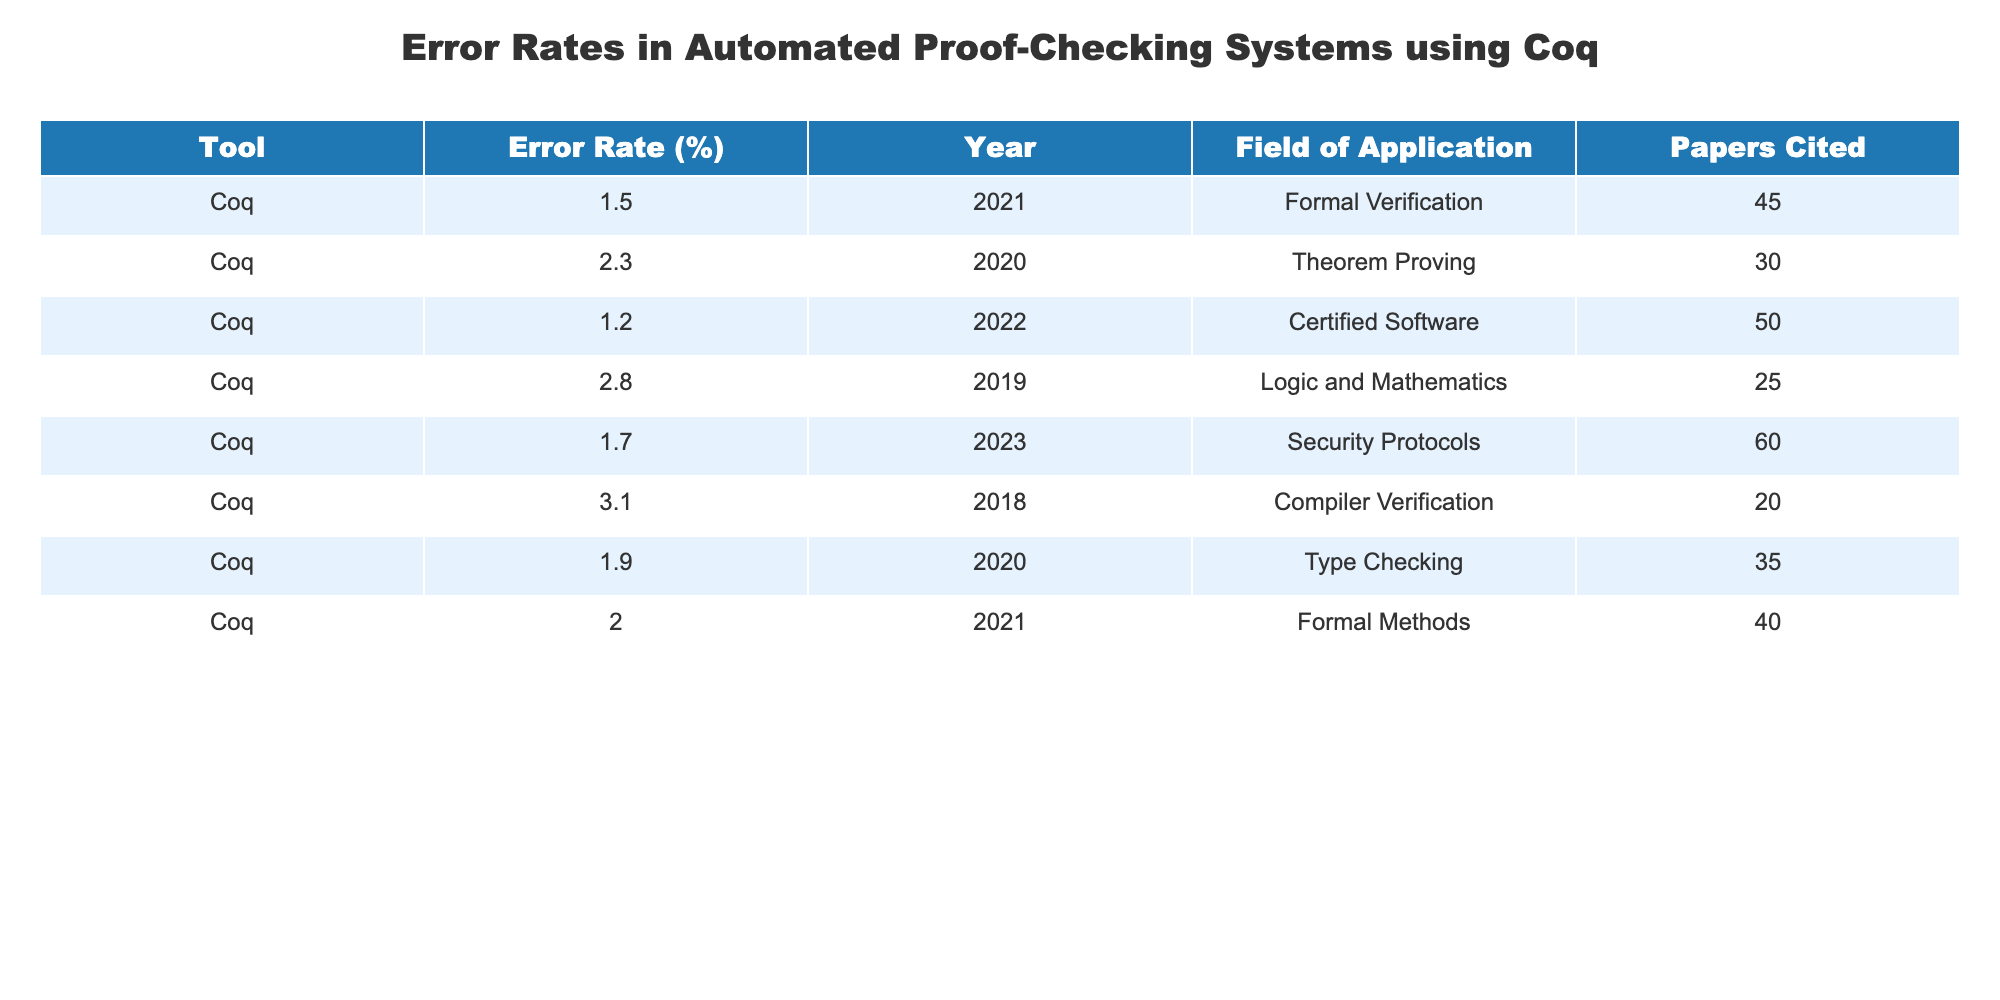What is the highest error rate recorded for Coq in the table? The table lists the error rates for Coq from various years and fields of application. Scanning through the "Error Rate (%)" column, the highest value recorded is 3.1%.
Answer: 3.1% What year was the lowest error rate reported? By examining the "Error Rate (%)" column, the lowest value is 1.2%, which corresponds to the year 2022. Therefore, the year 2022 had the lowest error rate.
Answer: 2022 How many different fields of application are represented in this table? The table includes unique fields of application listed in the "Field of Application" column. By counting the distinct entries, there are six different fields represented.
Answer: 6 What is the average error rate for the years listed? To find the average error rate, sum all rates: 1.5 + 2.3 + 1.2 + 2.8 + 1.7 + 3.1 + 1.9 + 2.0 = 16.5. There are 8 entries, so the average is 16.5 / 8 = 2.0625, which rounds to 2.06.
Answer: 2.06 Did the error rate for Coq in security protocols increase or decrease from the previous year? The error rate listed for security protocols in 2023 is 1.7%. The previous rate for 2022 (which is certified software) is 1.2%. Since we don't have the direct comparison to 2022 security protocols, we cannot determine a trend for security protocols specifically. However, in general, we see other fields may fluctuate.
Answer: Not applicable Can you list the error rates in chronological order from the table? The error rates can be arranged based on the "Year" column in ascending order: 3.1% (2018), 2.8% (2019), 2.3% (2020), 1.9% (2020), 1.5% (2021), 2.0% (2021), 1.2% (2022), 1.7% (2023).
Answer: 3.1%, 2.8%, 2.3%, 1.9%, 1.5%, 2.0%, 1.2%, 1.7% Was there an increase in the error rate for Coq from 2019 to 2020? The error rate for Coq in 2019 is 2.8%, while in 2020, the rates are 2.3% for theorem proving and 1.9% for type checking. Both rates for 2020 are lower than the rate for 2019, indicating a decrease, not an increase.
Answer: No What is the total number of papers cited for error rates above 2%? From the "Error Rate (%)" column, the entries with rates above 2% are 2.3 (30 papers), 2.8 (25 papers), and 3.1 (20 papers). Summing the papers: 30 + 25 + 20 = 75 papers cited for these rates.
Answer: 75 